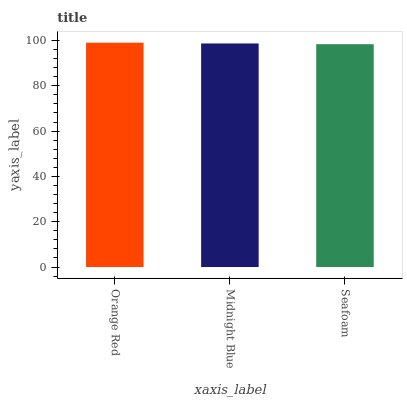Is Midnight Blue the minimum?
Answer yes or no. No. Is Midnight Blue the maximum?
Answer yes or no. No. Is Orange Red greater than Midnight Blue?
Answer yes or no. Yes. Is Midnight Blue less than Orange Red?
Answer yes or no. Yes. Is Midnight Blue greater than Orange Red?
Answer yes or no. No. Is Orange Red less than Midnight Blue?
Answer yes or no. No. Is Midnight Blue the high median?
Answer yes or no. Yes. Is Midnight Blue the low median?
Answer yes or no. Yes. Is Orange Red the high median?
Answer yes or no. No. Is Orange Red the low median?
Answer yes or no. No. 